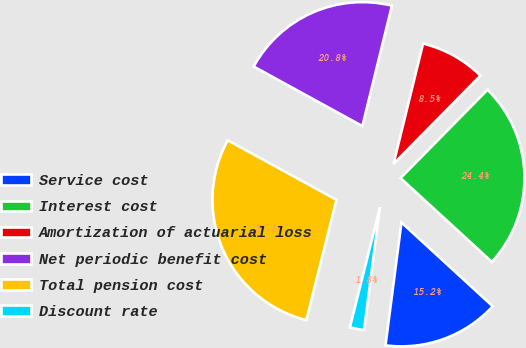<chart> <loc_0><loc_0><loc_500><loc_500><pie_chart><fcel>Service cost<fcel>Interest cost<fcel>Amortization of actuarial loss<fcel>Net periodic benefit cost<fcel>Total pension cost<fcel>Discount rate<nl><fcel>15.23%<fcel>24.45%<fcel>8.55%<fcel>20.85%<fcel>29.08%<fcel>1.85%<nl></chart> 